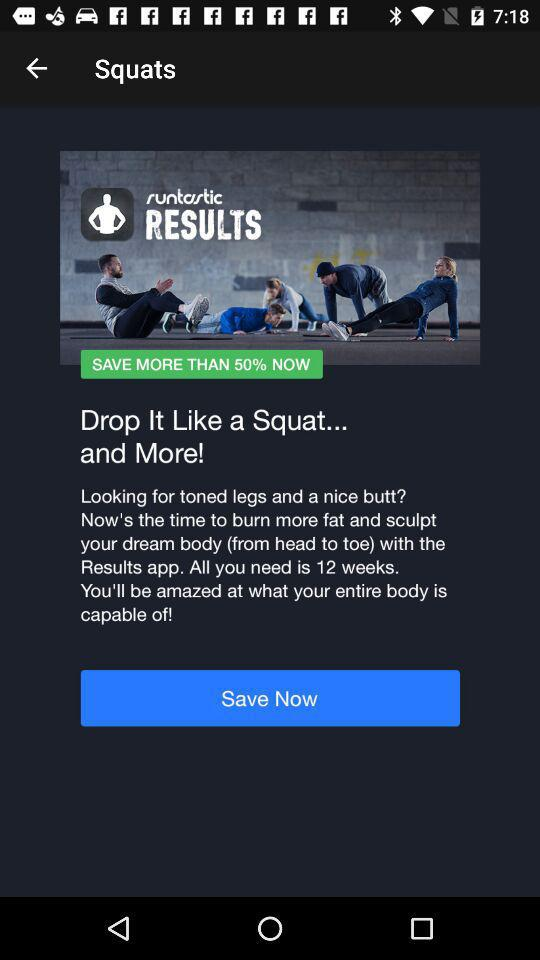What's percentage can I save on this application while buying?
When the provided information is insufficient, respond with <no answer>. <no answer> 